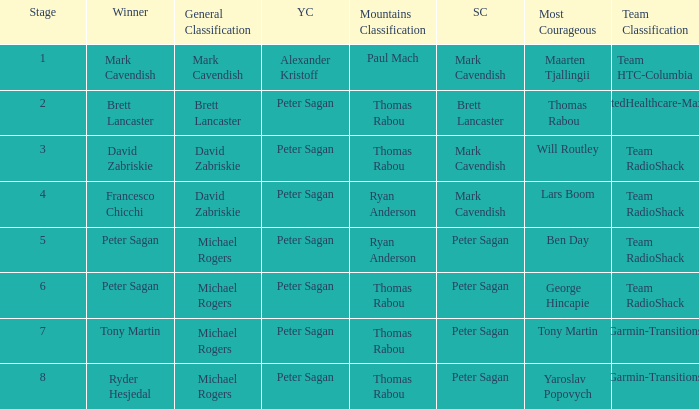When Ryan Anderson won the mountains classification, and Michael Rogers won the general classification, who won the sprint classification? Peter Sagan. 